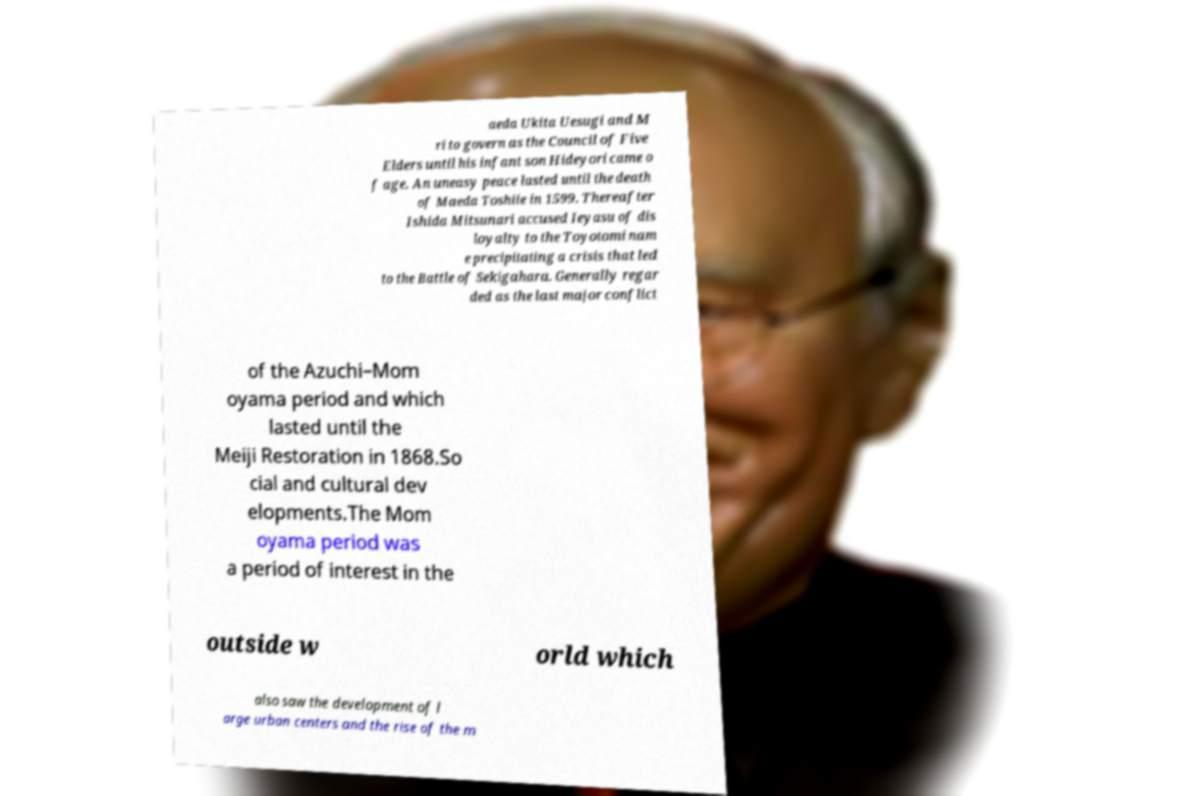Please identify and transcribe the text found in this image. aeda Ukita Uesugi and M ri to govern as the Council of Five Elders until his infant son Hideyori came o f age. An uneasy peace lasted until the death of Maeda Toshiie in 1599. Thereafter Ishida Mitsunari accused Ieyasu of dis loyalty to the Toyotomi nam e precipitating a crisis that led to the Battle of Sekigahara. Generally regar ded as the last major conflict of the Azuchi–Mom oyama period and which lasted until the Meiji Restoration in 1868.So cial and cultural dev elopments.The Mom oyama period was a period of interest in the outside w orld which also saw the development of l arge urban centers and the rise of the m 